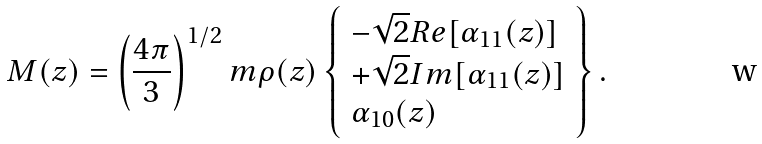Convert formula to latex. <formula><loc_0><loc_0><loc_500><loc_500>M ( z ) = \left ( \frac { 4 \pi } { 3 } \right ) ^ { 1 / 2 } m \rho ( z ) \left \{ \begin{array} { l l l } - \sqrt { 2 } { R e } { [ \alpha _ { 1 1 } ( z ) ] } \\ + \sqrt { 2 } { I m } { [ \alpha _ { 1 1 } ( z ) ] } \\ \alpha _ { 1 0 } ( z ) \end{array} \right \} .</formula> 